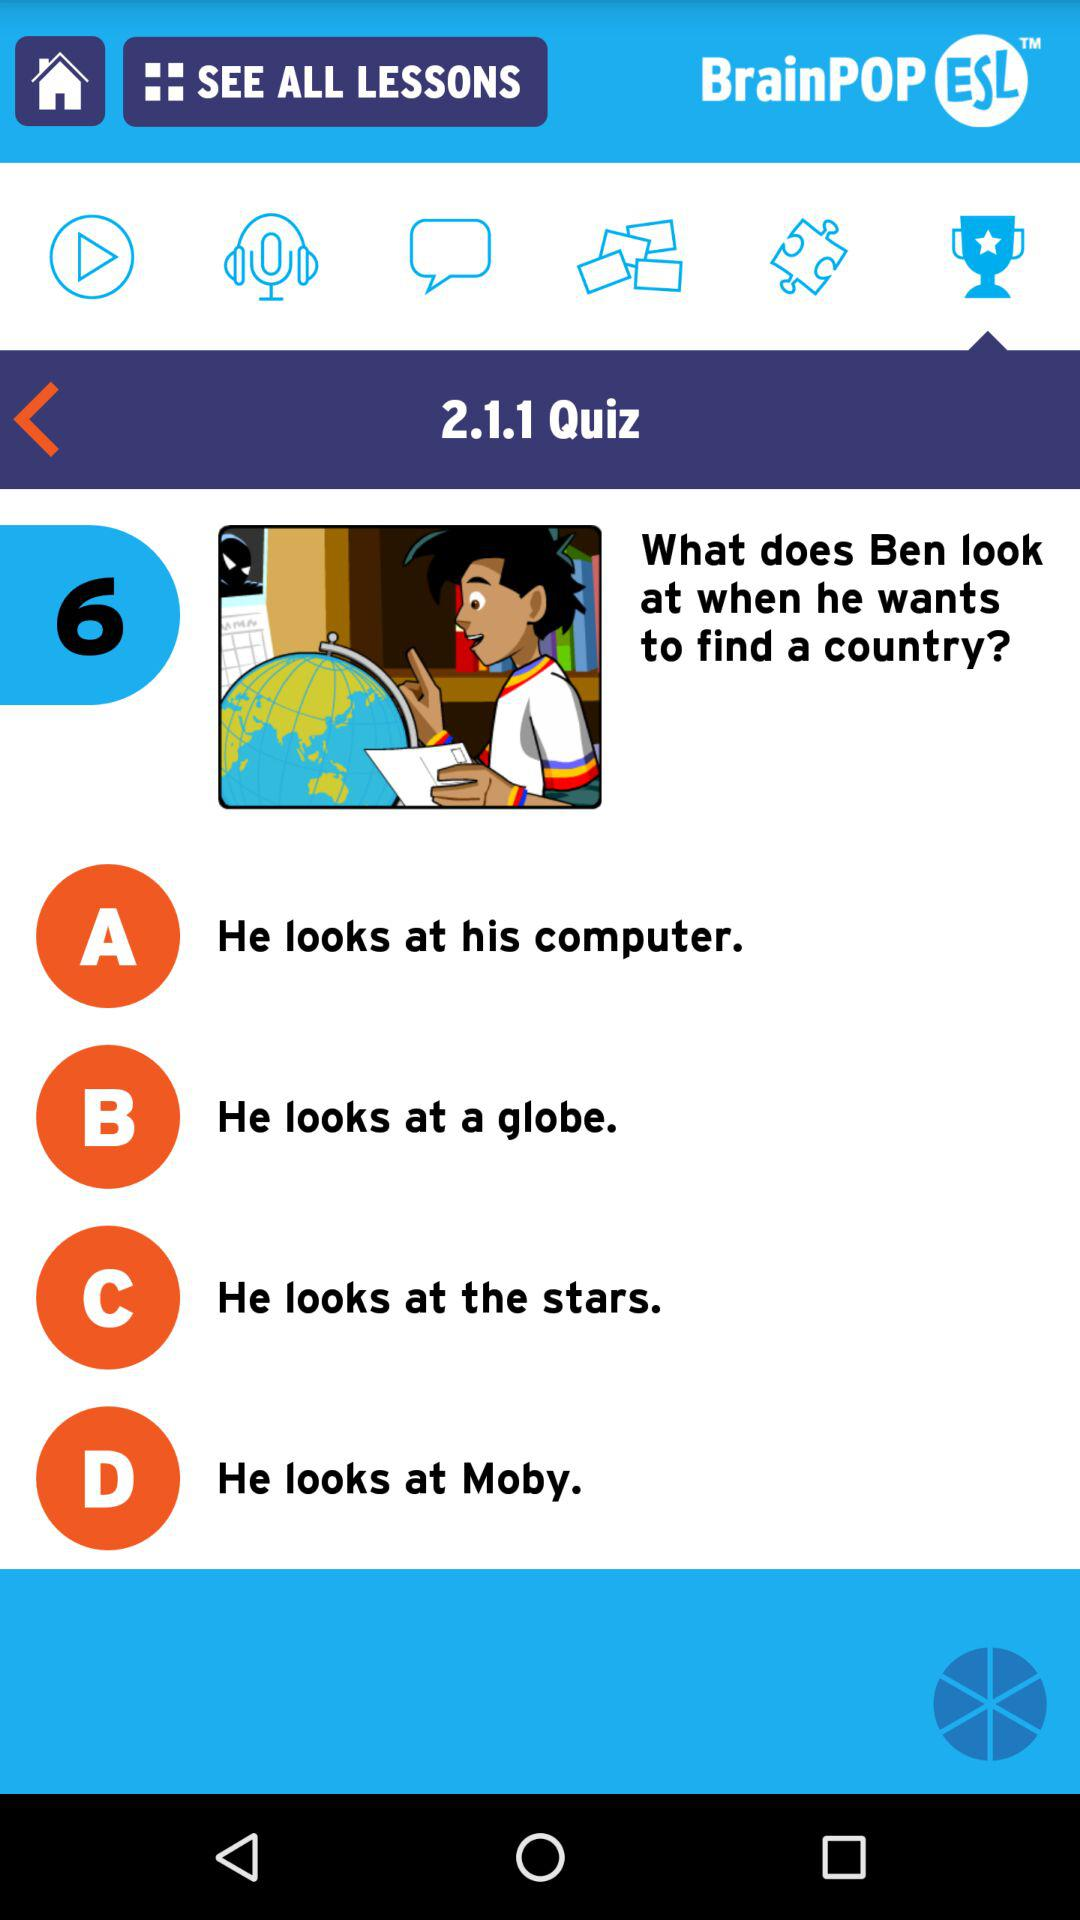How many choices are there on this quiz?
Answer the question using a single word or phrase. 4 